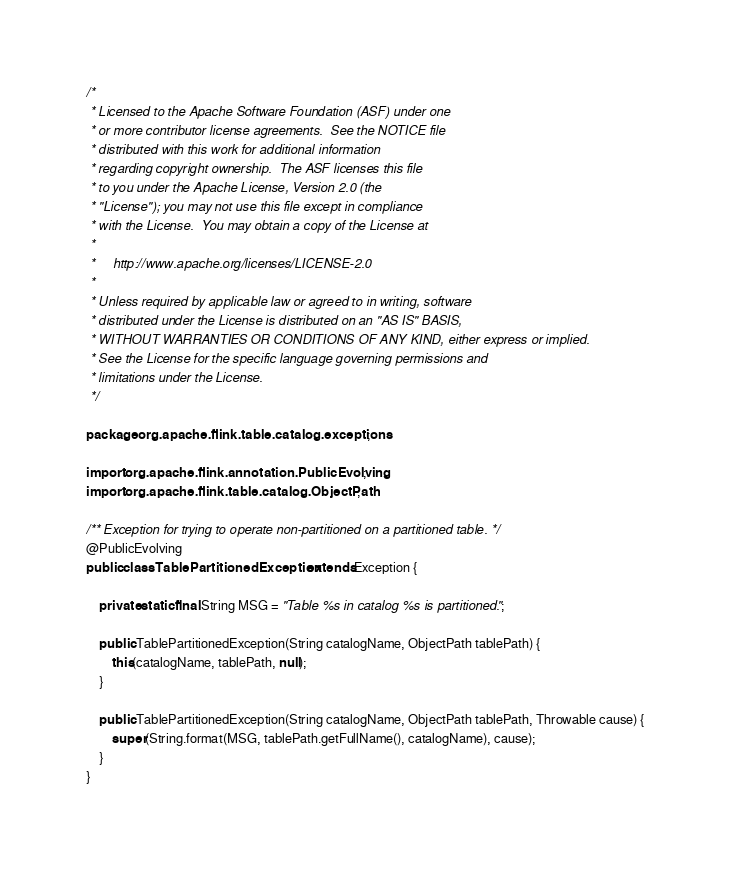<code> <loc_0><loc_0><loc_500><loc_500><_Java_>/*
 * Licensed to the Apache Software Foundation (ASF) under one
 * or more contributor license agreements.  See the NOTICE file
 * distributed with this work for additional information
 * regarding copyright ownership.  The ASF licenses this file
 * to you under the Apache License, Version 2.0 (the
 * "License"); you may not use this file except in compliance
 * with the License.  You may obtain a copy of the License at
 *
 *     http://www.apache.org/licenses/LICENSE-2.0
 *
 * Unless required by applicable law or agreed to in writing, software
 * distributed under the License is distributed on an "AS IS" BASIS,
 * WITHOUT WARRANTIES OR CONDITIONS OF ANY KIND, either express or implied.
 * See the License for the specific language governing permissions and
 * limitations under the License.
 */

package org.apache.flink.table.catalog.exceptions;

import org.apache.flink.annotation.PublicEvolving;
import org.apache.flink.table.catalog.ObjectPath;

/** Exception for trying to operate non-partitioned on a partitioned table. */
@PublicEvolving
public class TablePartitionedException extends Exception {

    private static final String MSG = "Table %s in catalog %s is partitioned.";

    public TablePartitionedException(String catalogName, ObjectPath tablePath) {
        this(catalogName, tablePath, null);
    }

    public TablePartitionedException(String catalogName, ObjectPath tablePath, Throwable cause) {
        super(String.format(MSG, tablePath.getFullName(), catalogName), cause);
    }
}
</code> 